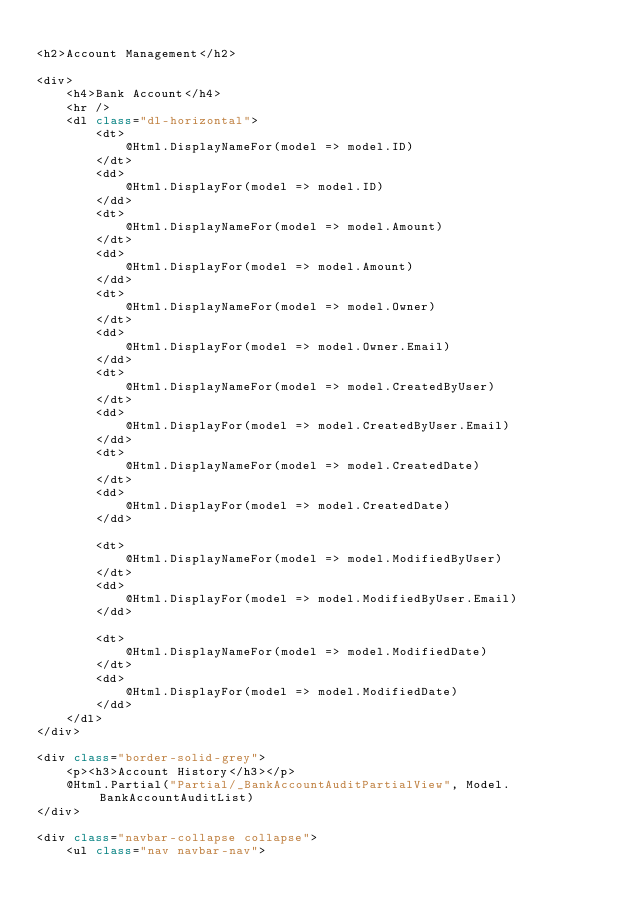<code> <loc_0><loc_0><loc_500><loc_500><_C#_>
<h2>Account Management</h2>

<div>
    <h4>Bank Account</h4>
    <hr />
    <dl class="dl-horizontal">
        <dt>
            @Html.DisplayNameFor(model => model.ID)
        </dt>
        <dd>
            @Html.DisplayFor(model => model.ID)
        </dd>
        <dt>
            @Html.DisplayNameFor(model => model.Amount)
        </dt>
        <dd>
            @Html.DisplayFor(model => model.Amount)
        </dd>
        <dt>
            @Html.DisplayNameFor(model => model.Owner)
        </dt>
        <dd>
            @Html.DisplayFor(model => model.Owner.Email)
        </dd>
        <dt>
            @Html.DisplayNameFor(model => model.CreatedByUser)
        </dt>
        <dd>
            @Html.DisplayFor(model => model.CreatedByUser.Email)
        </dd>
        <dt>
            @Html.DisplayNameFor(model => model.CreatedDate)
        </dt>
        <dd>
            @Html.DisplayFor(model => model.CreatedDate)
        </dd>

        <dt>
            @Html.DisplayNameFor(model => model.ModifiedByUser)
        </dt>
        <dd>
            @Html.DisplayFor(model => model.ModifiedByUser.Email)
        </dd>

        <dt>
            @Html.DisplayNameFor(model => model.ModifiedDate)
        </dt>
        <dd>
            @Html.DisplayFor(model => model.ModifiedDate)
        </dd> 
    </dl>
</div>

<div class="border-solid-grey">
    <p><h3>Account History</h3></p>
    @Html.Partial("Partial/_BankAccountAuditPartialView", Model.BankAccountAuditList)
</div>

<div class="navbar-collapse collapse">
    <ul class="nav navbar-nav"></code> 